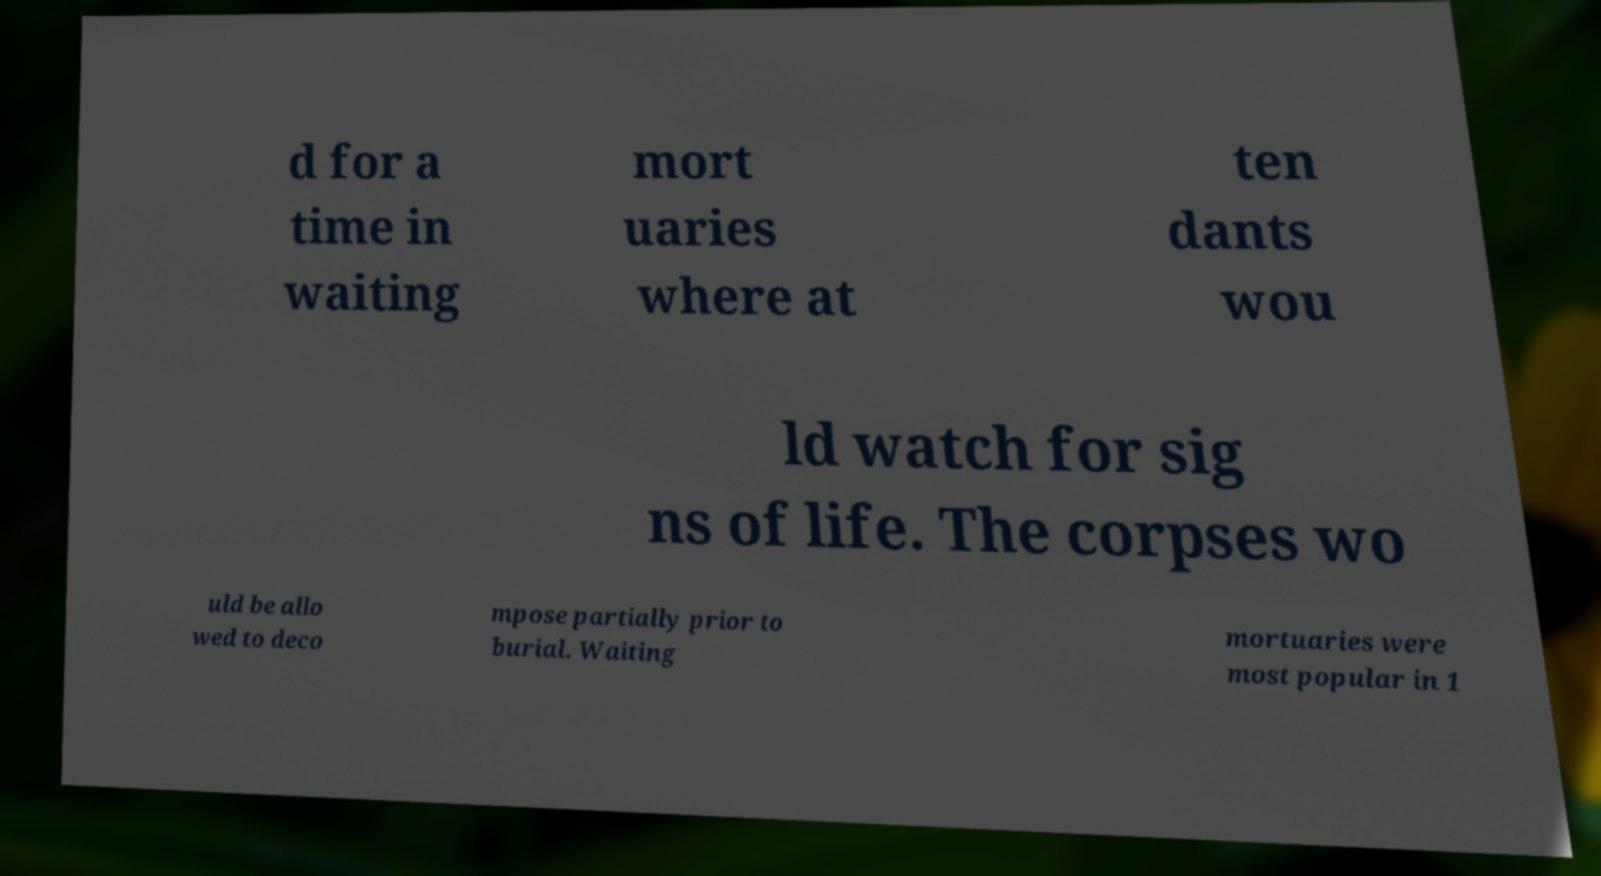Could you assist in decoding the text presented in this image and type it out clearly? d for a time in waiting mort uaries where at ten dants wou ld watch for sig ns of life. The corpses wo uld be allo wed to deco mpose partially prior to burial. Waiting mortuaries were most popular in 1 